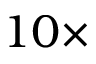<formula> <loc_0><loc_0><loc_500><loc_500>1 0 \times</formula> 